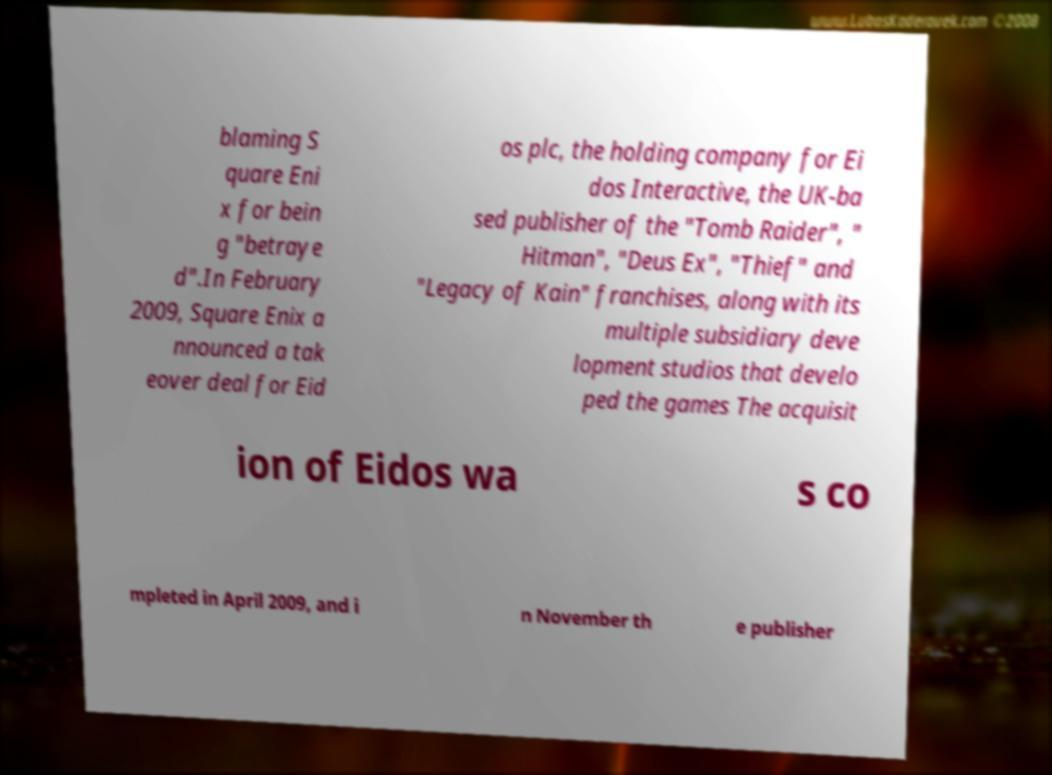There's text embedded in this image that I need extracted. Can you transcribe it verbatim? blaming S quare Eni x for bein g "betraye d".In February 2009, Square Enix a nnounced a tak eover deal for Eid os plc, the holding company for Ei dos Interactive, the UK-ba sed publisher of the "Tomb Raider", " Hitman", "Deus Ex", "Thief" and "Legacy of Kain" franchises, along with its multiple subsidiary deve lopment studios that develo ped the games The acquisit ion of Eidos wa s co mpleted in April 2009, and i n November th e publisher 